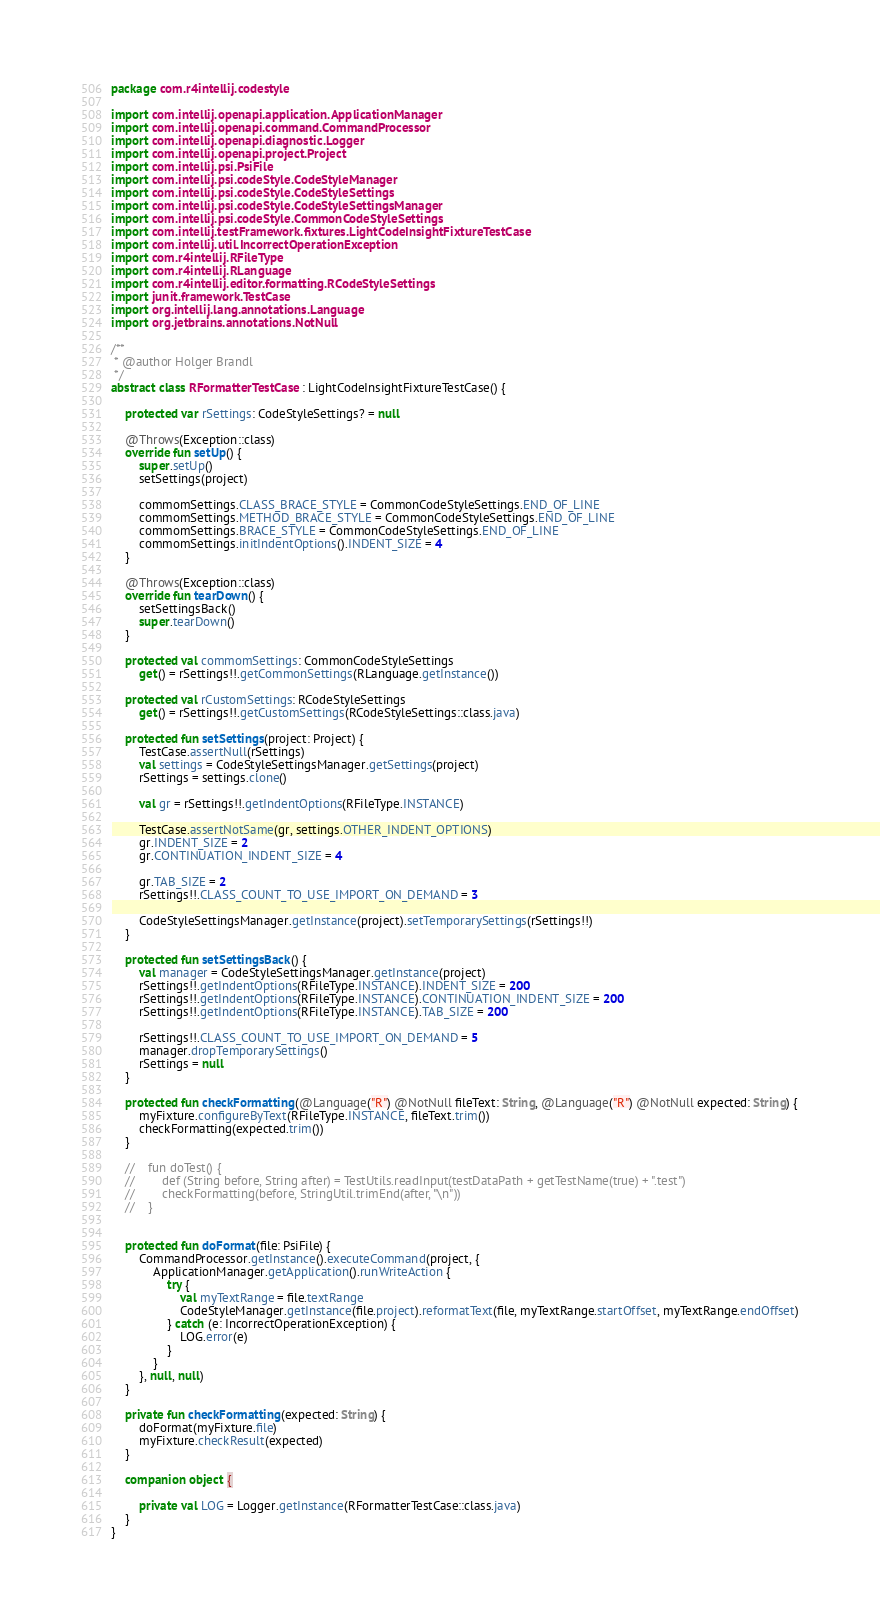<code> <loc_0><loc_0><loc_500><loc_500><_Kotlin_>package com.r4intellij.codestyle

import com.intellij.openapi.application.ApplicationManager
import com.intellij.openapi.command.CommandProcessor
import com.intellij.openapi.diagnostic.Logger
import com.intellij.openapi.project.Project
import com.intellij.psi.PsiFile
import com.intellij.psi.codeStyle.CodeStyleManager
import com.intellij.psi.codeStyle.CodeStyleSettings
import com.intellij.psi.codeStyle.CodeStyleSettingsManager
import com.intellij.psi.codeStyle.CommonCodeStyleSettings
import com.intellij.testFramework.fixtures.LightCodeInsightFixtureTestCase
import com.intellij.util.IncorrectOperationException
import com.r4intellij.RFileType
import com.r4intellij.RLanguage
import com.r4intellij.editor.formatting.RCodeStyleSettings
import junit.framework.TestCase
import org.intellij.lang.annotations.Language
import org.jetbrains.annotations.NotNull

/**
 * @author Holger Brandl
 */
abstract class RFormatterTestCase : LightCodeInsightFixtureTestCase() {

    protected var rSettings: CodeStyleSettings? = null

    @Throws(Exception::class)
    override fun setUp() {
        super.setUp()
        setSettings(project)

        commomSettings.CLASS_BRACE_STYLE = CommonCodeStyleSettings.END_OF_LINE
        commomSettings.METHOD_BRACE_STYLE = CommonCodeStyleSettings.END_OF_LINE
        commomSettings.BRACE_STYLE = CommonCodeStyleSettings.END_OF_LINE
        commomSettings.initIndentOptions().INDENT_SIZE = 4
    }

    @Throws(Exception::class)
    override fun tearDown() {
        setSettingsBack()
        super.tearDown()
    }

    protected val commomSettings: CommonCodeStyleSettings
        get() = rSettings!!.getCommonSettings(RLanguage.getInstance())

    protected val rCustomSettings: RCodeStyleSettings
        get() = rSettings!!.getCustomSettings(RCodeStyleSettings::class.java)

    protected fun setSettings(project: Project) {
        TestCase.assertNull(rSettings)
        val settings = CodeStyleSettingsManager.getSettings(project)
        rSettings = settings.clone()

        val gr = rSettings!!.getIndentOptions(RFileType.INSTANCE)

        TestCase.assertNotSame(gr, settings.OTHER_INDENT_OPTIONS)
        gr.INDENT_SIZE = 2
        gr.CONTINUATION_INDENT_SIZE = 4

        gr.TAB_SIZE = 2
        rSettings!!.CLASS_COUNT_TO_USE_IMPORT_ON_DEMAND = 3

        CodeStyleSettingsManager.getInstance(project).setTemporarySettings(rSettings!!)
    }

    protected fun setSettingsBack() {
        val manager = CodeStyleSettingsManager.getInstance(project)
        rSettings!!.getIndentOptions(RFileType.INSTANCE).INDENT_SIZE = 200
        rSettings!!.getIndentOptions(RFileType.INSTANCE).CONTINUATION_INDENT_SIZE = 200
        rSettings!!.getIndentOptions(RFileType.INSTANCE).TAB_SIZE = 200

        rSettings!!.CLASS_COUNT_TO_USE_IMPORT_ON_DEMAND = 5
        manager.dropTemporarySettings()
        rSettings = null
    }

    protected fun checkFormatting(@Language("R") @NotNull fileText: String, @Language("R") @NotNull expected: String) {
        myFixture.configureByText(RFileType.INSTANCE, fileText.trim())
        checkFormatting(expected.trim())
    }

    //    fun doTest() {
    //        def (String before, String after) = TestUtils.readInput(testDataPath + getTestName(true) + ".test")
    //        checkFormatting(before, StringUtil.trimEnd(after, "\n"))
    //    }


    protected fun doFormat(file: PsiFile) {
        CommandProcessor.getInstance().executeCommand(project, {
            ApplicationManager.getApplication().runWriteAction {
                try {
                    val myTextRange = file.textRange
                    CodeStyleManager.getInstance(file.project).reformatText(file, myTextRange.startOffset, myTextRange.endOffset)
                } catch (e: IncorrectOperationException) {
                    LOG.error(e)
                }
            }
        }, null, null)
    }

    private fun checkFormatting(expected: String) {
        doFormat(myFixture.file)
        myFixture.checkResult(expected)
    }

    companion object {

        private val LOG = Logger.getInstance(RFormatterTestCase::class.java)
    }
}
</code> 